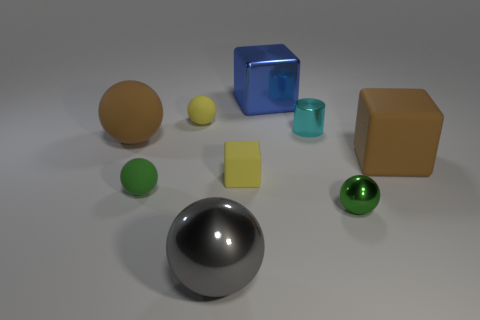Are there any big shiny balls that have the same color as the tiny cylinder?
Keep it short and to the point. No. There is a big ball that is behind the large matte object to the right of the gray thing; what is its color?
Offer a terse response. Brown. Are there fewer metal spheres that are behind the blue metallic thing than big brown rubber objects in front of the green metal object?
Your answer should be compact. No. Do the brown ball and the gray thing have the same size?
Offer a very short reply. Yes. The metal object that is behind the small metallic sphere and to the right of the blue metal object has what shape?
Provide a short and direct response. Cylinder. What number of tiny green objects are the same material as the yellow sphere?
Ensure brevity in your answer.  1. What number of big brown rubber objects are to the left of the yellow object that is in front of the large matte sphere?
Your response must be concise. 1. There is a tiny yellow matte object that is on the right side of the yellow sphere that is behind the small green object on the left side of the blue cube; what shape is it?
Offer a terse response. Cube. The thing that is the same color as the big rubber ball is what size?
Give a very brief answer. Large. What number of objects are either brown rubber balls or small cyan metallic things?
Give a very brief answer. 2. 